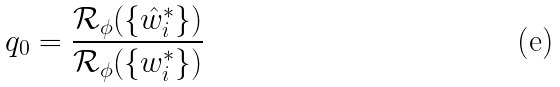Convert formula to latex. <formula><loc_0><loc_0><loc_500><loc_500>q _ { 0 } = \frac { \mathcal { R } _ { \phi } ( \{ \hat { w } _ { i } ^ { * } \} ) } { \mathcal { R } _ { \phi } ( \{ w _ { i } ^ { * } \} ) }</formula> 